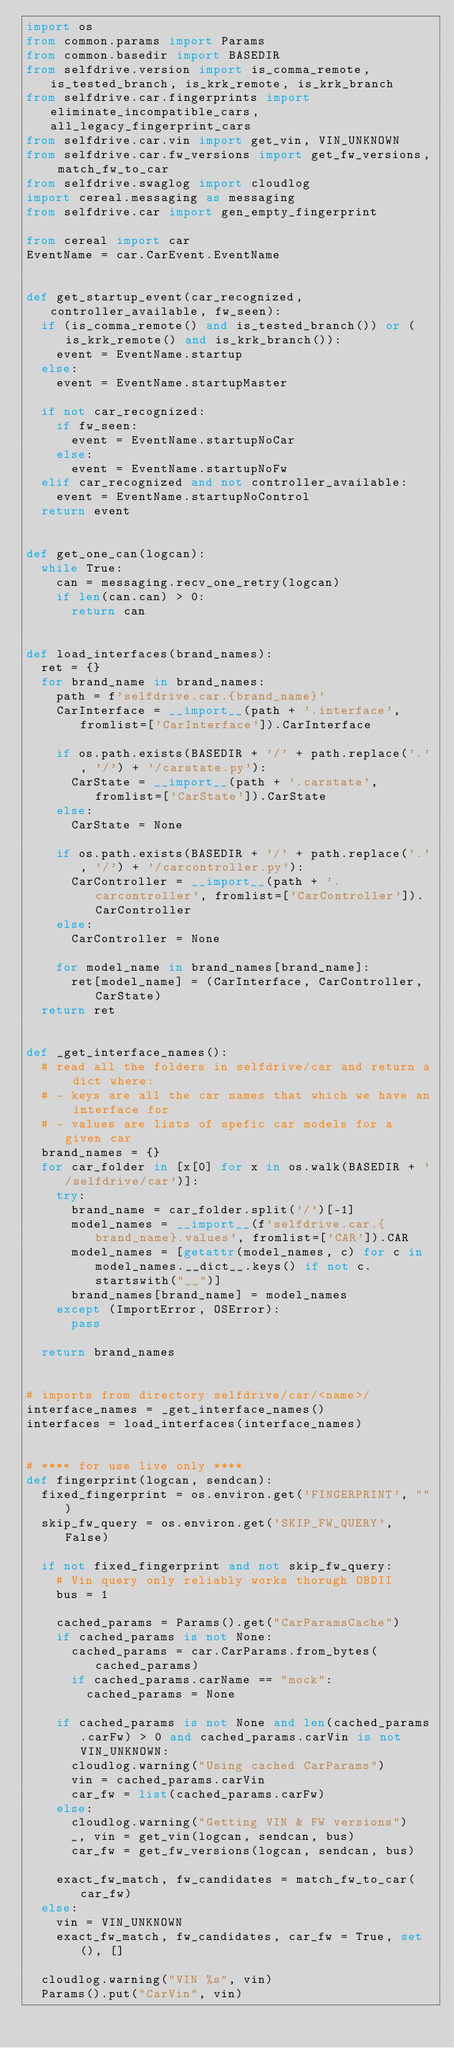Convert code to text. <code><loc_0><loc_0><loc_500><loc_500><_Python_>import os
from common.params import Params
from common.basedir import BASEDIR
from selfdrive.version import is_comma_remote, is_tested_branch, is_krk_remote, is_krk_branch
from selfdrive.car.fingerprints import eliminate_incompatible_cars, all_legacy_fingerprint_cars
from selfdrive.car.vin import get_vin, VIN_UNKNOWN
from selfdrive.car.fw_versions import get_fw_versions, match_fw_to_car
from selfdrive.swaglog import cloudlog
import cereal.messaging as messaging
from selfdrive.car import gen_empty_fingerprint

from cereal import car
EventName = car.CarEvent.EventName


def get_startup_event(car_recognized, controller_available, fw_seen):
  if (is_comma_remote() and is_tested_branch()) or (is_krk_remote() and is_krk_branch()):
    event = EventName.startup
  else:
    event = EventName.startupMaster

  if not car_recognized:
    if fw_seen:
      event = EventName.startupNoCar
    else:
      event = EventName.startupNoFw
  elif car_recognized and not controller_available:
    event = EventName.startupNoControl
  return event


def get_one_can(logcan):
  while True:
    can = messaging.recv_one_retry(logcan)
    if len(can.can) > 0:
      return can


def load_interfaces(brand_names):
  ret = {}
  for brand_name in brand_names:
    path = f'selfdrive.car.{brand_name}'
    CarInterface = __import__(path + '.interface', fromlist=['CarInterface']).CarInterface

    if os.path.exists(BASEDIR + '/' + path.replace('.', '/') + '/carstate.py'):
      CarState = __import__(path + '.carstate', fromlist=['CarState']).CarState
    else:
      CarState = None

    if os.path.exists(BASEDIR + '/' + path.replace('.', '/') + '/carcontroller.py'):
      CarController = __import__(path + '.carcontroller', fromlist=['CarController']).CarController
    else:
      CarController = None

    for model_name in brand_names[brand_name]:
      ret[model_name] = (CarInterface, CarController, CarState)
  return ret


def _get_interface_names():
  # read all the folders in selfdrive/car and return a dict where:
  # - keys are all the car names that which we have an interface for
  # - values are lists of spefic car models for a given car
  brand_names = {}
  for car_folder in [x[0] for x in os.walk(BASEDIR + '/selfdrive/car')]:
    try:
      brand_name = car_folder.split('/')[-1]
      model_names = __import__(f'selfdrive.car.{brand_name}.values', fromlist=['CAR']).CAR
      model_names = [getattr(model_names, c) for c in model_names.__dict__.keys() if not c.startswith("__")]
      brand_names[brand_name] = model_names
    except (ImportError, OSError):
      pass

  return brand_names


# imports from directory selfdrive/car/<name>/
interface_names = _get_interface_names()
interfaces = load_interfaces(interface_names)


# **** for use live only ****
def fingerprint(logcan, sendcan):
  fixed_fingerprint = os.environ.get('FINGERPRINT', "")
  skip_fw_query = os.environ.get('SKIP_FW_QUERY', False)

  if not fixed_fingerprint and not skip_fw_query:
    # Vin query only reliably works thorugh OBDII
    bus = 1

    cached_params = Params().get("CarParamsCache")
    if cached_params is not None:
      cached_params = car.CarParams.from_bytes(cached_params)
      if cached_params.carName == "mock":
        cached_params = None

    if cached_params is not None and len(cached_params.carFw) > 0 and cached_params.carVin is not VIN_UNKNOWN:
      cloudlog.warning("Using cached CarParams")
      vin = cached_params.carVin
      car_fw = list(cached_params.carFw)
    else:
      cloudlog.warning("Getting VIN & FW versions")
      _, vin = get_vin(logcan, sendcan, bus)
      car_fw = get_fw_versions(logcan, sendcan, bus)

    exact_fw_match, fw_candidates = match_fw_to_car(car_fw)
  else:
    vin = VIN_UNKNOWN
    exact_fw_match, fw_candidates, car_fw = True, set(), []

  cloudlog.warning("VIN %s", vin)
  Params().put("CarVin", vin)
</code> 